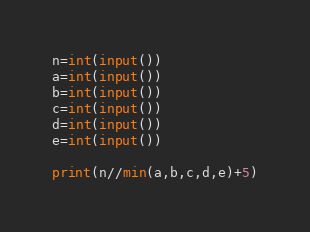Convert code to text. <code><loc_0><loc_0><loc_500><loc_500><_Python_>n=int(input())
a=int(input())
b=int(input())
c=int(input())
d=int(input())
e=int(input())

print(n//min(a,b,c,d,e)+5)</code> 